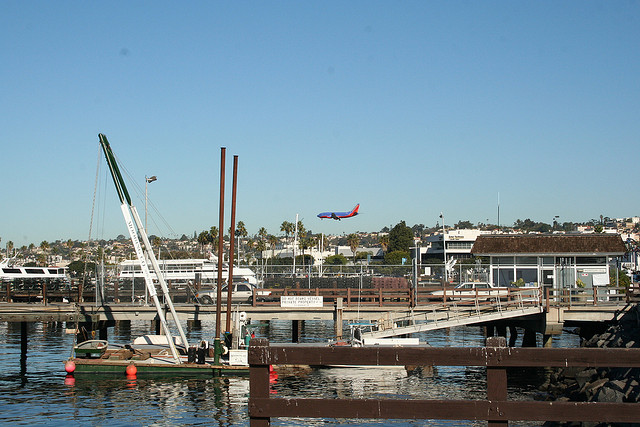What is soaring through the air?
A. airplane
B. bat
C. kite
D. zeppelin
Answer with the option's letter from the given choices directly. A 